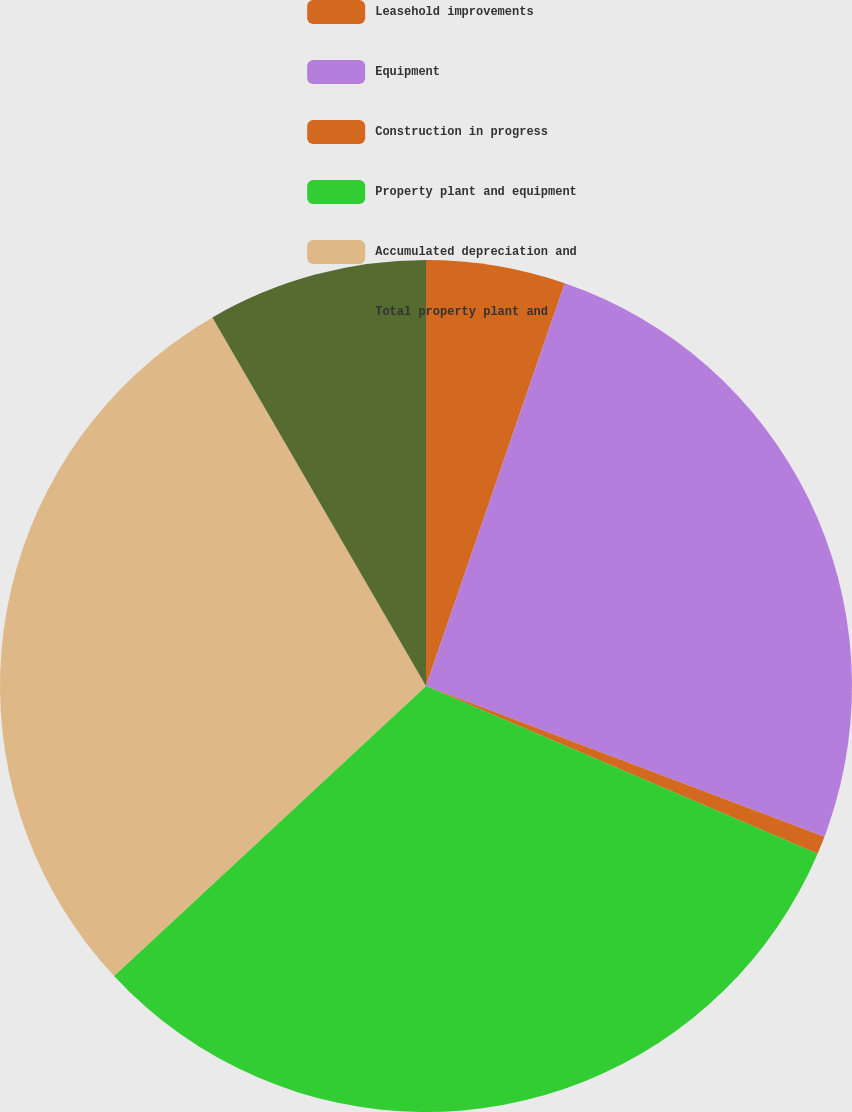<chart> <loc_0><loc_0><loc_500><loc_500><pie_chart><fcel>Leasehold improvements<fcel>Equipment<fcel>Construction in progress<fcel>Property plant and equipment<fcel>Accumulated depreciation and<fcel>Total property plant and<nl><fcel>5.28%<fcel>25.48%<fcel>0.68%<fcel>31.64%<fcel>28.56%<fcel>8.36%<nl></chart> 